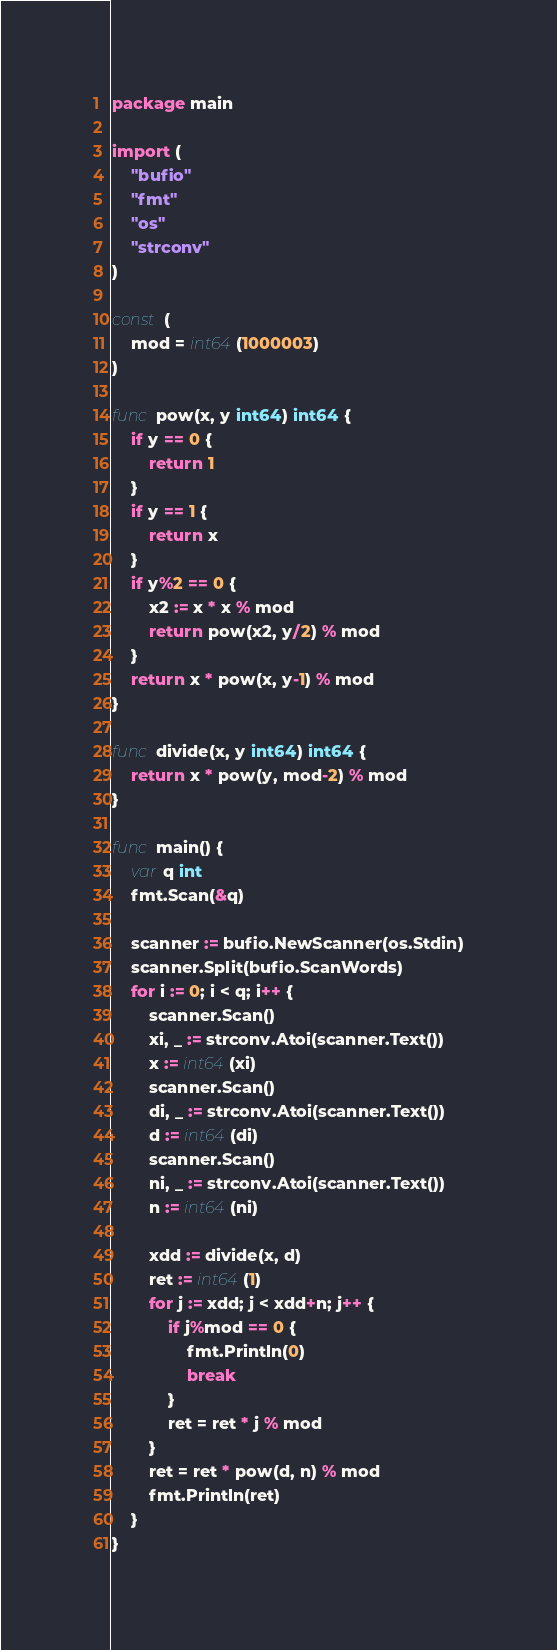Convert code to text. <code><loc_0><loc_0><loc_500><loc_500><_Go_>package main

import (
	"bufio"
	"fmt"
	"os"
	"strconv"
)

const (
	mod = int64(1000003)
)

func pow(x, y int64) int64 {
	if y == 0 {
		return 1
	}
	if y == 1 {
		return x
	}
	if y%2 == 0 {
		x2 := x * x % mod
		return pow(x2, y/2) % mod
	}
	return x * pow(x, y-1) % mod
}

func divide(x, y int64) int64 {
	return x * pow(y, mod-2) % mod
}

func main() {
	var q int
	fmt.Scan(&q)

	scanner := bufio.NewScanner(os.Stdin)
	scanner.Split(bufio.ScanWords)
	for i := 0; i < q; i++ {
		scanner.Scan()
		xi, _ := strconv.Atoi(scanner.Text())
		x := int64(xi)
		scanner.Scan()
		di, _ := strconv.Atoi(scanner.Text())
		d := int64(di)
		scanner.Scan()
		ni, _ := strconv.Atoi(scanner.Text())
		n := int64(ni)

		xdd := divide(x, d)
		ret := int64(1)
		for j := xdd; j < xdd+n; j++ {
			if j%mod == 0 {
				fmt.Println(0)
				break
			}
			ret = ret * j % mod
		}
		ret = ret * pow(d, n) % mod
		fmt.Println(ret)
	}
}
</code> 